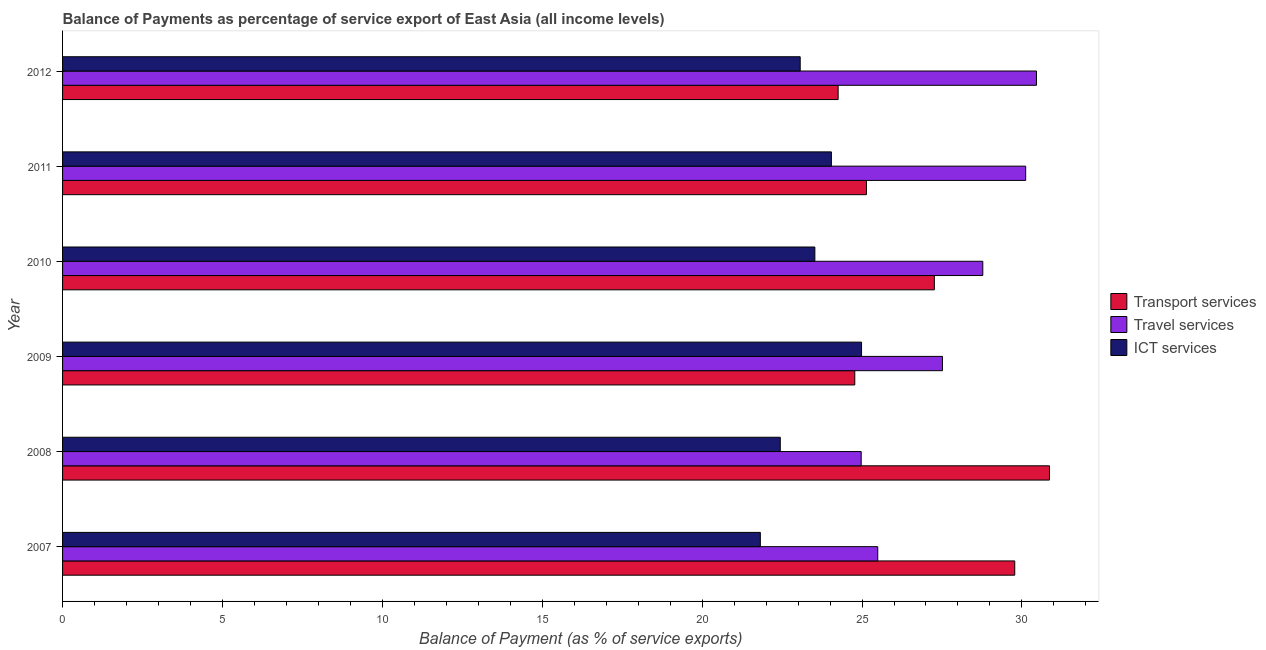How many different coloured bars are there?
Offer a very short reply. 3. How many groups of bars are there?
Ensure brevity in your answer.  6. Are the number of bars per tick equal to the number of legend labels?
Make the answer very short. Yes. How many bars are there on the 3rd tick from the top?
Your answer should be compact. 3. What is the balance of payment of ict services in 2007?
Your answer should be compact. 21.82. Across all years, what is the maximum balance of payment of transport services?
Ensure brevity in your answer.  30.86. Across all years, what is the minimum balance of payment of ict services?
Your answer should be compact. 21.82. In which year was the balance of payment of travel services maximum?
Keep it short and to the point. 2012. What is the total balance of payment of travel services in the graph?
Keep it short and to the point. 167.33. What is the difference between the balance of payment of ict services in 2007 and that in 2010?
Provide a succinct answer. -1.71. What is the difference between the balance of payment of transport services in 2007 and the balance of payment of ict services in 2009?
Keep it short and to the point. 4.79. What is the average balance of payment of transport services per year?
Keep it short and to the point. 27.01. In the year 2007, what is the difference between the balance of payment of travel services and balance of payment of transport services?
Ensure brevity in your answer.  -4.28. What is the ratio of the balance of payment of transport services in 2010 to that in 2011?
Make the answer very short. 1.08. Is the difference between the balance of payment of transport services in 2007 and 2010 greater than the difference between the balance of payment of ict services in 2007 and 2010?
Offer a terse response. Yes. What is the difference between the highest and the second highest balance of payment of ict services?
Offer a terse response. 0.94. What is the difference between the highest and the lowest balance of payment of transport services?
Provide a short and direct response. 6.61. Is the sum of the balance of payment of transport services in 2009 and 2010 greater than the maximum balance of payment of travel services across all years?
Offer a terse response. Yes. What does the 2nd bar from the top in 2010 represents?
Ensure brevity in your answer.  Travel services. What does the 2nd bar from the bottom in 2007 represents?
Provide a short and direct response. Travel services. What is the difference between two consecutive major ticks on the X-axis?
Provide a succinct answer. 5. How are the legend labels stacked?
Your answer should be very brief. Vertical. What is the title of the graph?
Your response must be concise. Balance of Payments as percentage of service export of East Asia (all income levels). Does "Profit Tax" appear as one of the legend labels in the graph?
Provide a short and direct response. No. What is the label or title of the X-axis?
Offer a terse response. Balance of Payment (as % of service exports). What is the Balance of Payment (as % of service exports) in Transport services in 2007?
Keep it short and to the point. 29.78. What is the Balance of Payment (as % of service exports) in Travel services in 2007?
Provide a succinct answer. 25.49. What is the Balance of Payment (as % of service exports) of ICT services in 2007?
Ensure brevity in your answer.  21.82. What is the Balance of Payment (as % of service exports) in Transport services in 2008?
Make the answer very short. 30.86. What is the Balance of Payment (as % of service exports) of Travel services in 2008?
Make the answer very short. 24.97. What is the Balance of Payment (as % of service exports) of ICT services in 2008?
Provide a succinct answer. 22.44. What is the Balance of Payment (as % of service exports) of Transport services in 2009?
Make the answer very short. 24.77. What is the Balance of Payment (as % of service exports) of Travel services in 2009?
Keep it short and to the point. 27.51. What is the Balance of Payment (as % of service exports) of ICT services in 2009?
Keep it short and to the point. 24.98. What is the Balance of Payment (as % of service exports) of Transport services in 2010?
Offer a terse response. 27.26. What is the Balance of Payment (as % of service exports) in Travel services in 2010?
Provide a succinct answer. 28.78. What is the Balance of Payment (as % of service exports) of ICT services in 2010?
Offer a very short reply. 23.53. What is the Balance of Payment (as % of service exports) of Transport services in 2011?
Ensure brevity in your answer.  25.14. What is the Balance of Payment (as % of service exports) of Travel services in 2011?
Make the answer very short. 30.12. What is the Balance of Payment (as % of service exports) of ICT services in 2011?
Your response must be concise. 24.04. What is the Balance of Payment (as % of service exports) in Transport services in 2012?
Keep it short and to the point. 24.25. What is the Balance of Payment (as % of service exports) in Travel services in 2012?
Ensure brevity in your answer.  30.46. What is the Balance of Payment (as % of service exports) of ICT services in 2012?
Provide a succinct answer. 23.07. Across all years, what is the maximum Balance of Payment (as % of service exports) of Transport services?
Keep it short and to the point. 30.86. Across all years, what is the maximum Balance of Payment (as % of service exports) in Travel services?
Provide a short and direct response. 30.46. Across all years, what is the maximum Balance of Payment (as % of service exports) in ICT services?
Your answer should be compact. 24.98. Across all years, what is the minimum Balance of Payment (as % of service exports) of Transport services?
Offer a terse response. 24.25. Across all years, what is the minimum Balance of Payment (as % of service exports) in Travel services?
Your answer should be very brief. 24.97. Across all years, what is the minimum Balance of Payment (as % of service exports) of ICT services?
Make the answer very short. 21.82. What is the total Balance of Payment (as % of service exports) of Transport services in the graph?
Provide a succinct answer. 162.06. What is the total Balance of Payment (as % of service exports) of Travel services in the graph?
Provide a short and direct response. 167.33. What is the total Balance of Payment (as % of service exports) in ICT services in the graph?
Give a very brief answer. 139.88. What is the difference between the Balance of Payment (as % of service exports) of Transport services in 2007 and that in 2008?
Your answer should be compact. -1.09. What is the difference between the Balance of Payment (as % of service exports) in Travel services in 2007 and that in 2008?
Keep it short and to the point. 0.52. What is the difference between the Balance of Payment (as % of service exports) in ICT services in 2007 and that in 2008?
Provide a succinct answer. -0.62. What is the difference between the Balance of Payment (as % of service exports) of Transport services in 2007 and that in 2009?
Keep it short and to the point. 5. What is the difference between the Balance of Payment (as % of service exports) of Travel services in 2007 and that in 2009?
Ensure brevity in your answer.  -2.02. What is the difference between the Balance of Payment (as % of service exports) in ICT services in 2007 and that in 2009?
Give a very brief answer. -3.16. What is the difference between the Balance of Payment (as % of service exports) of Transport services in 2007 and that in 2010?
Offer a terse response. 2.51. What is the difference between the Balance of Payment (as % of service exports) of Travel services in 2007 and that in 2010?
Offer a terse response. -3.29. What is the difference between the Balance of Payment (as % of service exports) in ICT services in 2007 and that in 2010?
Offer a terse response. -1.7. What is the difference between the Balance of Payment (as % of service exports) in Transport services in 2007 and that in 2011?
Provide a short and direct response. 4.64. What is the difference between the Balance of Payment (as % of service exports) in Travel services in 2007 and that in 2011?
Your answer should be very brief. -4.63. What is the difference between the Balance of Payment (as % of service exports) in ICT services in 2007 and that in 2011?
Offer a very short reply. -2.22. What is the difference between the Balance of Payment (as % of service exports) of Transport services in 2007 and that in 2012?
Keep it short and to the point. 5.52. What is the difference between the Balance of Payment (as % of service exports) of Travel services in 2007 and that in 2012?
Offer a terse response. -4.96. What is the difference between the Balance of Payment (as % of service exports) in ICT services in 2007 and that in 2012?
Make the answer very short. -1.25. What is the difference between the Balance of Payment (as % of service exports) of Transport services in 2008 and that in 2009?
Make the answer very short. 6.09. What is the difference between the Balance of Payment (as % of service exports) in Travel services in 2008 and that in 2009?
Offer a very short reply. -2.54. What is the difference between the Balance of Payment (as % of service exports) in ICT services in 2008 and that in 2009?
Provide a succinct answer. -2.54. What is the difference between the Balance of Payment (as % of service exports) of Transport services in 2008 and that in 2010?
Your response must be concise. 3.6. What is the difference between the Balance of Payment (as % of service exports) in Travel services in 2008 and that in 2010?
Offer a very short reply. -3.8. What is the difference between the Balance of Payment (as % of service exports) of ICT services in 2008 and that in 2010?
Your answer should be compact. -1.08. What is the difference between the Balance of Payment (as % of service exports) in Transport services in 2008 and that in 2011?
Offer a terse response. 5.72. What is the difference between the Balance of Payment (as % of service exports) of Travel services in 2008 and that in 2011?
Make the answer very short. -5.14. What is the difference between the Balance of Payment (as % of service exports) of ICT services in 2008 and that in 2011?
Give a very brief answer. -1.6. What is the difference between the Balance of Payment (as % of service exports) in Transport services in 2008 and that in 2012?
Keep it short and to the point. 6.61. What is the difference between the Balance of Payment (as % of service exports) in Travel services in 2008 and that in 2012?
Provide a short and direct response. -5.48. What is the difference between the Balance of Payment (as % of service exports) of ICT services in 2008 and that in 2012?
Provide a succinct answer. -0.62. What is the difference between the Balance of Payment (as % of service exports) of Transport services in 2009 and that in 2010?
Your answer should be compact. -2.49. What is the difference between the Balance of Payment (as % of service exports) of Travel services in 2009 and that in 2010?
Give a very brief answer. -1.26. What is the difference between the Balance of Payment (as % of service exports) of ICT services in 2009 and that in 2010?
Your response must be concise. 1.46. What is the difference between the Balance of Payment (as % of service exports) in Transport services in 2009 and that in 2011?
Your answer should be compact. -0.37. What is the difference between the Balance of Payment (as % of service exports) in Travel services in 2009 and that in 2011?
Make the answer very short. -2.6. What is the difference between the Balance of Payment (as % of service exports) of ICT services in 2009 and that in 2011?
Your answer should be very brief. 0.94. What is the difference between the Balance of Payment (as % of service exports) of Transport services in 2009 and that in 2012?
Make the answer very short. 0.52. What is the difference between the Balance of Payment (as % of service exports) in Travel services in 2009 and that in 2012?
Provide a succinct answer. -2.94. What is the difference between the Balance of Payment (as % of service exports) in ICT services in 2009 and that in 2012?
Ensure brevity in your answer.  1.92. What is the difference between the Balance of Payment (as % of service exports) of Transport services in 2010 and that in 2011?
Provide a succinct answer. 2.12. What is the difference between the Balance of Payment (as % of service exports) in Travel services in 2010 and that in 2011?
Offer a very short reply. -1.34. What is the difference between the Balance of Payment (as % of service exports) in ICT services in 2010 and that in 2011?
Your response must be concise. -0.52. What is the difference between the Balance of Payment (as % of service exports) of Transport services in 2010 and that in 2012?
Give a very brief answer. 3.01. What is the difference between the Balance of Payment (as % of service exports) in Travel services in 2010 and that in 2012?
Your response must be concise. -1.68. What is the difference between the Balance of Payment (as % of service exports) in ICT services in 2010 and that in 2012?
Make the answer very short. 0.46. What is the difference between the Balance of Payment (as % of service exports) in Transport services in 2011 and that in 2012?
Provide a succinct answer. 0.89. What is the difference between the Balance of Payment (as % of service exports) of Travel services in 2011 and that in 2012?
Make the answer very short. -0.34. What is the difference between the Balance of Payment (as % of service exports) of ICT services in 2011 and that in 2012?
Make the answer very short. 0.98. What is the difference between the Balance of Payment (as % of service exports) in Transport services in 2007 and the Balance of Payment (as % of service exports) in Travel services in 2008?
Keep it short and to the point. 4.8. What is the difference between the Balance of Payment (as % of service exports) of Transport services in 2007 and the Balance of Payment (as % of service exports) of ICT services in 2008?
Ensure brevity in your answer.  7.33. What is the difference between the Balance of Payment (as % of service exports) in Travel services in 2007 and the Balance of Payment (as % of service exports) in ICT services in 2008?
Your response must be concise. 3.05. What is the difference between the Balance of Payment (as % of service exports) in Transport services in 2007 and the Balance of Payment (as % of service exports) in Travel services in 2009?
Keep it short and to the point. 2.26. What is the difference between the Balance of Payment (as % of service exports) of Transport services in 2007 and the Balance of Payment (as % of service exports) of ICT services in 2009?
Provide a short and direct response. 4.79. What is the difference between the Balance of Payment (as % of service exports) in Travel services in 2007 and the Balance of Payment (as % of service exports) in ICT services in 2009?
Ensure brevity in your answer.  0.51. What is the difference between the Balance of Payment (as % of service exports) of Transport services in 2007 and the Balance of Payment (as % of service exports) of ICT services in 2010?
Provide a short and direct response. 6.25. What is the difference between the Balance of Payment (as % of service exports) in Travel services in 2007 and the Balance of Payment (as % of service exports) in ICT services in 2010?
Make the answer very short. 1.97. What is the difference between the Balance of Payment (as % of service exports) in Transport services in 2007 and the Balance of Payment (as % of service exports) in Travel services in 2011?
Provide a short and direct response. -0.34. What is the difference between the Balance of Payment (as % of service exports) of Transport services in 2007 and the Balance of Payment (as % of service exports) of ICT services in 2011?
Keep it short and to the point. 5.73. What is the difference between the Balance of Payment (as % of service exports) in Travel services in 2007 and the Balance of Payment (as % of service exports) in ICT services in 2011?
Your answer should be compact. 1.45. What is the difference between the Balance of Payment (as % of service exports) in Transport services in 2007 and the Balance of Payment (as % of service exports) in Travel services in 2012?
Your answer should be very brief. -0.68. What is the difference between the Balance of Payment (as % of service exports) in Transport services in 2007 and the Balance of Payment (as % of service exports) in ICT services in 2012?
Offer a terse response. 6.71. What is the difference between the Balance of Payment (as % of service exports) in Travel services in 2007 and the Balance of Payment (as % of service exports) in ICT services in 2012?
Give a very brief answer. 2.42. What is the difference between the Balance of Payment (as % of service exports) in Transport services in 2008 and the Balance of Payment (as % of service exports) in Travel services in 2009?
Ensure brevity in your answer.  3.35. What is the difference between the Balance of Payment (as % of service exports) of Transport services in 2008 and the Balance of Payment (as % of service exports) of ICT services in 2009?
Make the answer very short. 5.88. What is the difference between the Balance of Payment (as % of service exports) of Travel services in 2008 and the Balance of Payment (as % of service exports) of ICT services in 2009?
Offer a terse response. -0.01. What is the difference between the Balance of Payment (as % of service exports) of Transport services in 2008 and the Balance of Payment (as % of service exports) of Travel services in 2010?
Offer a very short reply. 2.09. What is the difference between the Balance of Payment (as % of service exports) of Transport services in 2008 and the Balance of Payment (as % of service exports) of ICT services in 2010?
Ensure brevity in your answer.  7.34. What is the difference between the Balance of Payment (as % of service exports) of Travel services in 2008 and the Balance of Payment (as % of service exports) of ICT services in 2010?
Your answer should be compact. 1.45. What is the difference between the Balance of Payment (as % of service exports) in Transport services in 2008 and the Balance of Payment (as % of service exports) in Travel services in 2011?
Offer a terse response. 0.74. What is the difference between the Balance of Payment (as % of service exports) of Transport services in 2008 and the Balance of Payment (as % of service exports) of ICT services in 2011?
Your answer should be compact. 6.82. What is the difference between the Balance of Payment (as % of service exports) of Travel services in 2008 and the Balance of Payment (as % of service exports) of ICT services in 2011?
Keep it short and to the point. 0.93. What is the difference between the Balance of Payment (as % of service exports) in Transport services in 2008 and the Balance of Payment (as % of service exports) in Travel services in 2012?
Provide a short and direct response. 0.41. What is the difference between the Balance of Payment (as % of service exports) in Transport services in 2008 and the Balance of Payment (as % of service exports) in ICT services in 2012?
Provide a succinct answer. 7.8. What is the difference between the Balance of Payment (as % of service exports) of Travel services in 2008 and the Balance of Payment (as % of service exports) of ICT services in 2012?
Offer a terse response. 1.91. What is the difference between the Balance of Payment (as % of service exports) in Transport services in 2009 and the Balance of Payment (as % of service exports) in Travel services in 2010?
Give a very brief answer. -4. What is the difference between the Balance of Payment (as % of service exports) in Transport services in 2009 and the Balance of Payment (as % of service exports) in ICT services in 2010?
Your answer should be compact. 1.25. What is the difference between the Balance of Payment (as % of service exports) in Travel services in 2009 and the Balance of Payment (as % of service exports) in ICT services in 2010?
Keep it short and to the point. 3.99. What is the difference between the Balance of Payment (as % of service exports) in Transport services in 2009 and the Balance of Payment (as % of service exports) in Travel services in 2011?
Provide a succinct answer. -5.34. What is the difference between the Balance of Payment (as % of service exports) of Transport services in 2009 and the Balance of Payment (as % of service exports) of ICT services in 2011?
Provide a short and direct response. 0.73. What is the difference between the Balance of Payment (as % of service exports) of Travel services in 2009 and the Balance of Payment (as % of service exports) of ICT services in 2011?
Your response must be concise. 3.47. What is the difference between the Balance of Payment (as % of service exports) of Transport services in 2009 and the Balance of Payment (as % of service exports) of Travel services in 2012?
Offer a terse response. -5.68. What is the difference between the Balance of Payment (as % of service exports) in Transport services in 2009 and the Balance of Payment (as % of service exports) in ICT services in 2012?
Make the answer very short. 1.71. What is the difference between the Balance of Payment (as % of service exports) in Travel services in 2009 and the Balance of Payment (as % of service exports) in ICT services in 2012?
Offer a terse response. 4.45. What is the difference between the Balance of Payment (as % of service exports) in Transport services in 2010 and the Balance of Payment (as % of service exports) in Travel services in 2011?
Make the answer very short. -2.86. What is the difference between the Balance of Payment (as % of service exports) in Transport services in 2010 and the Balance of Payment (as % of service exports) in ICT services in 2011?
Your answer should be compact. 3.22. What is the difference between the Balance of Payment (as % of service exports) in Travel services in 2010 and the Balance of Payment (as % of service exports) in ICT services in 2011?
Make the answer very short. 4.73. What is the difference between the Balance of Payment (as % of service exports) in Transport services in 2010 and the Balance of Payment (as % of service exports) in Travel services in 2012?
Offer a very short reply. -3.19. What is the difference between the Balance of Payment (as % of service exports) of Transport services in 2010 and the Balance of Payment (as % of service exports) of ICT services in 2012?
Provide a short and direct response. 4.19. What is the difference between the Balance of Payment (as % of service exports) in Travel services in 2010 and the Balance of Payment (as % of service exports) in ICT services in 2012?
Give a very brief answer. 5.71. What is the difference between the Balance of Payment (as % of service exports) in Transport services in 2011 and the Balance of Payment (as % of service exports) in Travel services in 2012?
Offer a very short reply. -5.32. What is the difference between the Balance of Payment (as % of service exports) in Transport services in 2011 and the Balance of Payment (as % of service exports) in ICT services in 2012?
Provide a succinct answer. 2.07. What is the difference between the Balance of Payment (as % of service exports) in Travel services in 2011 and the Balance of Payment (as % of service exports) in ICT services in 2012?
Make the answer very short. 7.05. What is the average Balance of Payment (as % of service exports) of Transport services per year?
Your answer should be compact. 27.01. What is the average Balance of Payment (as % of service exports) in Travel services per year?
Your response must be concise. 27.89. What is the average Balance of Payment (as % of service exports) in ICT services per year?
Your response must be concise. 23.31. In the year 2007, what is the difference between the Balance of Payment (as % of service exports) of Transport services and Balance of Payment (as % of service exports) of Travel services?
Make the answer very short. 4.28. In the year 2007, what is the difference between the Balance of Payment (as % of service exports) in Transport services and Balance of Payment (as % of service exports) in ICT services?
Your answer should be very brief. 7.96. In the year 2007, what is the difference between the Balance of Payment (as % of service exports) in Travel services and Balance of Payment (as % of service exports) in ICT services?
Provide a short and direct response. 3.67. In the year 2008, what is the difference between the Balance of Payment (as % of service exports) of Transport services and Balance of Payment (as % of service exports) of Travel services?
Make the answer very short. 5.89. In the year 2008, what is the difference between the Balance of Payment (as % of service exports) of Transport services and Balance of Payment (as % of service exports) of ICT services?
Offer a very short reply. 8.42. In the year 2008, what is the difference between the Balance of Payment (as % of service exports) of Travel services and Balance of Payment (as % of service exports) of ICT services?
Provide a short and direct response. 2.53. In the year 2009, what is the difference between the Balance of Payment (as % of service exports) in Transport services and Balance of Payment (as % of service exports) in Travel services?
Make the answer very short. -2.74. In the year 2009, what is the difference between the Balance of Payment (as % of service exports) of Transport services and Balance of Payment (as % of service exports) of ICT services?
Offer a very short reply. -0.21. In the year 2009, what is the difference between the Balance of Payment (as % of service exports) in Travel services and Balance of Payment (as % of service exports) in ICT services?
Provide a succinct answer. 2.53. In the year 2010, what is the difference between the Balance of Payment (as % of service exports) in Transport services and Balance of Payment (as % of service exports) in Travel services?
Your answer should be very brief. -1.51. In the year 2010, what is the difference between the Balance of Payment (as % of service exports) in Transport services and Balance of Payment (as % of service exports) in ICT services?
Provide a succinct answer. 3.74. In the year 2010, what is the difference between the Balance of Payment (as % of service exports) in Travel services and Balance of Payment (as % of service exports) in ICT services?
Offer a terse response. 5.25. In the year 2011, what is the difference between the Balance of Payment (as % of service exports) in Transport services and Balance of Payment (as % of service exports) in Travel services?
Provide a succinct answer. -4.98. In the year 2011, what is the difference between the Balance of Payment (as % of service exports) of Transport services and Balance of Payment (as % of service exports) of ICT services?
Keep it short and to the point. 1.1. In the year 2011, what is the difference between the Balance of Payment (as % of service exports) of Travel services and Balance of Payment (as % of service exports) of ICT services?
Your answer should be very brief. 6.08. In the year 2012, what is the difference between the Balance of Payment (as % of service exports) of Transport services and Balance of Payment (as % of service exports) of Travel services?
Provide a short and direct response. -6.2. In the year 2012, what is the difference between the Balance of Payment (as % of service exports) of Transport services and Balance of Payment (as % of service exports) of ICT services?
Offer a very short reply. 1.19. In the year 2012, what is the difference between the Balance of Payment (as % of service exports) of Travel services and Balance of Payment (as % of service exports) of ICT services?
Ensure brevity in your answer.  7.39. What is the ratio of the Balance of Payment (as % of service exports) of Transport services in 2007 to that in 2008?
Provide a short and direct response. 0.96. What is the ratio of the Balance of Payment (as % of service exports) in Travel services in 2007 to that in 2008?
Give a very brief answer. 1.02. What is the ratio of the Balance of Payment (as % of service exports) in ICT services in 2007 to that in 2008?
Offer a very short reply. 0.97. What is the ratio of the Balance of Payment (as % of service exports) in Transport services in 2007 to that in 2009?
Give a very brief answer. 1.2. What is the ratio of the Balance of Payment (as % of service exports) in Travel services in 2007 to that in 2009?
Your answer should be compact. 0.93. What is the ratio of the Balance of Payment (as % of service exports) of ICT services in 2007 to that in 2009?
Make the answer very short. 0.87. What is the ratio of the Balance of Payment (as % of service exports) in Transport services in 2007 to that in 2010?
Make the answer very short. 1.09. What is the ratio of the Balance of Payment (as % of service exports) in Travel services in 2007 to that in 2010?
Ensure brevity in your answer.  0.89. What is the ratio of the Balance of Payment (as % of service exports) in ICT services in 2007 to that in 2010?
Offer a terse response. 0.93. What is the ratio of the Balance of Payment (as % of service exports) in Transport services in 2007 to that in 2011?
Your answer should be very brief. 1.18. What is the ratio of the Balance of Payment (as % of service exports) of Travel services in 2007 to that in 2011?
Provide a short and direct response. 0.85. What is the ratio of the Balance of Payment (as % of service exports) of ICT services in 2007 to that in 2011?
Provide a short and direct response. 0.91. What is the ratio of the Balance of Payment (as % of service exports) of Transport services in 2007 to that in 2012?
Ensure brevity in your answer.  1.23. What is the ratio of the Balance of Payment (as % of service exports) in Travel services in 2007 to that in 2012?
Give a very brief answer. 0.84. What is the ratio of the Balance of Payment (as % of service exports) of ICT services in 2007 to that in 2012?
Ensure brevity in your answer.  0.95. What is the ratio of the Balance of Payment (as % of service exports) in Transport services in 2008 to that in 2009?
Give a very brief answer. 1.25. What is the ratio of the Balance of Payment (as % of service exports) of Travel services in 2008 to that in 2009?
Your answer should be very brief. 0.91. What is the ratio of the Balance of Payment (as % of service exports) of ICT services in 2008 to that in 2009?
Provide a short and direct response. 0.9. What is the ratio of the Balance of Payment (as % of service exports) of Transport services in 2008 to that in 2010?
Offer a very short reply. 1.13. What is the ratio of the Balance of Payment (as % of service exports) in Travel services in 2008 to that in 2010?
Ensure brevity in your answer.  0.87. What is the ratio of the Balance of Payment (as % of service exports) in ICT services in 2008 to that in 2010?
Your answer should be very brief. 0.95. What is the ratio of the Balance of Payment (as % of service exports) of Transport services in 2008 to that in 2011?
Your response must be concise. 1.23. What is the ratio of the Balance of Payment (as % of service exports) in Travel services in 2008 to that in 2011?
Provide a short and direct response. 0.83. What is the ratio of the Balance of Payment (as % of service exports) in ICT services in 2008 to that in 2011?
Keep it short and to the point. 0.93. What is the ratio of the Balance of Payment (as % of service exports) of Transport services in 2008 to that in 2012?
Offer a terse response. 1.27. What is the ratio of the Balance of Payment (as % of service exports) in Travel services in 2008 to that in 2012?
Your answer should be compact. 0.82. What is the ratio of the Balance of Payment (as % of service exports) of ICT services in 2008 to that in 2012?
Provide a short and direct response. 0.97. What is the ratio of the Balance of Payment (as % of service exports) of Transport services in 2009 to that in 2010?
Your response must be concise. 0.91. What is the ratio of the Balance of Payment (as % of service exports) of Travel services in 2009 to that in 2010?
Keep it short and to the point. 0.96. What is the ratio of the Balance of Payment (as % of service exports) of ICT services in 2009 to that in 2010?
Your answer should be very brief. 1.06. What is the ratio of the Balance of Payment (as % of service exports) of Transport services in 2009 to that in 2011?
Ensure brevity in your answer.  0.99. What is the ratio of the Balance of Payment (as % of service exports) in Travel services in 2009 to that in 2011?
Keep it short and to the point. 0.91. What is the ratio of the Balance of Payment (as % of service exports) of ICT services in 2009 to that in 2011?
Offer a very short reply. 1.04. What is the ratio of the Balance of Payment (as % of service exports) of Transport services in 2009 to that in 2012?
Offer a terse response. 1.02. What is the ratio of the Balance of Payment (as % of service exports) in Travel services in 2009 to that in 2012?
Give a very brief answer. 0.9. What is the ratio of the Balance of Payment (as % of service exports) of ICT services in 2009 to that in 2012?
Offer a very short reply. 1.08. What is the ratio of the Balance of Payment (as % of service exports) in Transport services in 2010 to that in 2011?
Your response must be concise. 1.08. What is the ratio of the Balance of Payment (as % of service exports) of Travel services in 2010 to that in 2011?
Provide a succinct answer. 0.96. What is the ratio of the Balance of Payment (as % of service exports) of ICT services in 2010 to that in 2011?
Offer a very short reply. 0.98. What is the ratio of the Balance of Payment (as % of service exports) of Transport services in 2010 to that in 2012?
Your answer should be very brief. 1.12. What is the ratio of the Balance of Payment (as % of service exports) in Travel services in 2010 to that in 2012?
Provide a short and direct response. 0.94. What is the ratio of the Balance of Payment (as % of service exports) of ICT services in 2010 to that in 2012?
Provide a succinct answer. 1.02. What is the ratio of the Balance of Payment (as % of service exports) of Transport services in 2011 to that in 2012?
Give a very brief answer. 1.04. What is the ratio of the Balance of Payment (as % of service exports) of Travel services in 2011 to that in 2012?
Your response must be concise. 0.99. What is the ratio of the Balance of Payment (as % of service exports) of ICT services in 2011 to that in 2012?
Ensure brevity in your answer.  1.04. What is the difference between the highest and the second highest Balance of Payment (as % of service exports) in Transport services?
Give a very brief answer. 1.09. What is the difference between the highest and the second highest Balance of Payment (as % of service exports) of Travel services?
Your response must be concise. 0.34. What is the difference between the highest and the second highest Balance of Payment (as % of service exports) of ICT services?
Provide a short and direct response. 0.94. What is the difference between the highest and the lowest Balance of Payment (as % of service exports) of Transport services?
Give a very brief answer. 6.61. What is the difference between the highest and the lowest Balance of Payment (as % of service exports) in Travel services?
Provide a succinct answer. 5.48. What is the difference between the highest and the lowest Balance of Payment (as % of service exports) of ICT services?
Provide a short and direct response. 3.16. 